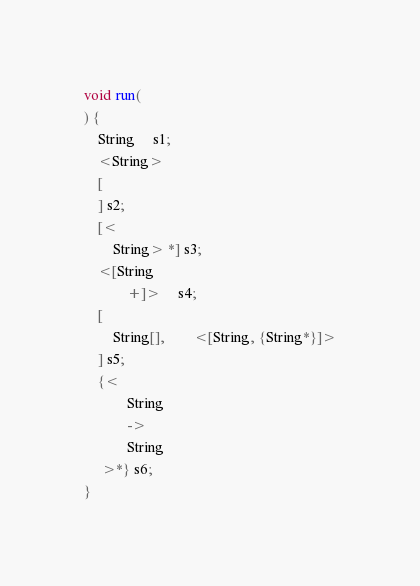Convert code to text. <code><loc_0><loc_0><loc_500><loc_500><_Ceylon_>void run(
) {
    String     s1;
    <String>
    [
    ] s2;
    [<
        String> *] s3;
    <[String
            +]>     s4;
    [
        String[],        <[String, {String*}]>
    ] s5;
    {<
            String
            ->
            String
     >*} s6;
}
</code> 